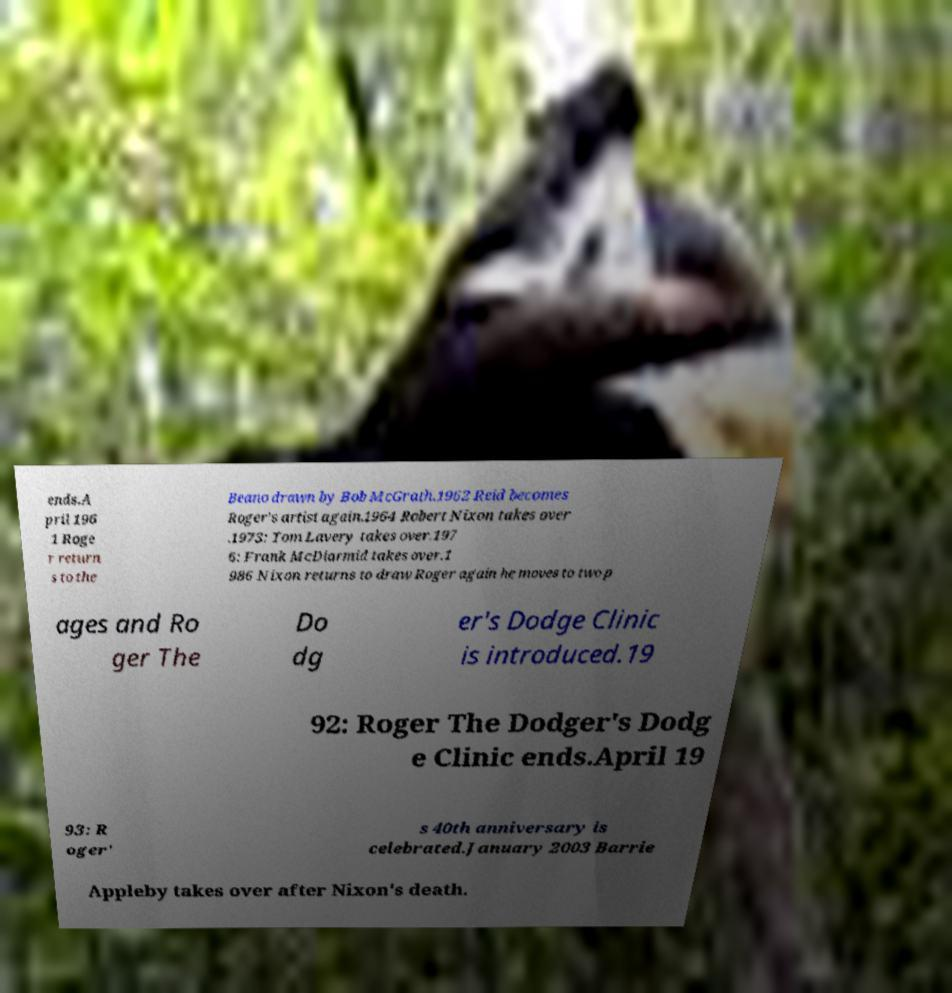There's text embedded in this image that I need extracted. Can you transcribe it verbatim? ends.A pril 196 1 Roge r return s to the Beano drawn by Bob McGrath.1962 Reid becomes Roger's artist again.1964 Robert Nixon takes over .1973: Tom Lavery takes over.197 6: Frank McDiarmid takes over.1 986 Nixon returns to draw Roger again he moves to two p ages and Ro ger The Do dg er's Dodge Clinic is introduced.19 92: Roger The Dodger's Dodg e Clinic ends.April 19 93: R oger' s 40th anniversary is celebrated.January 2003 Barrie Appleby takes over after Nixon's death. 